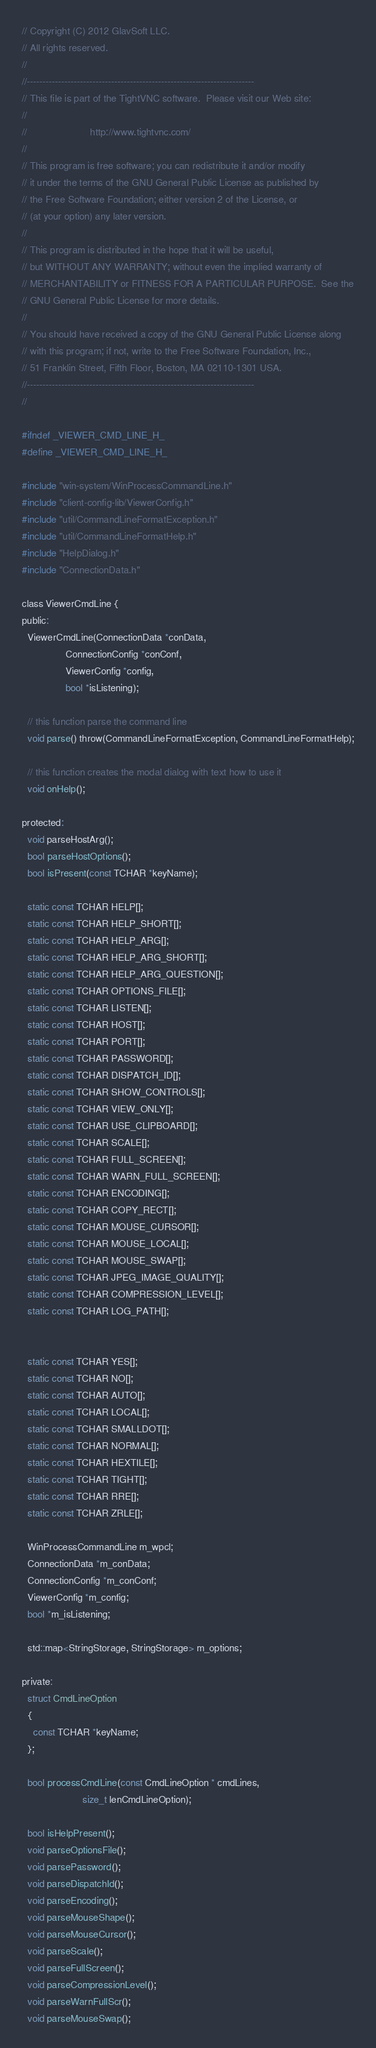Convert code to text. <code><loc_0><loc_0><loc_500><loc_500><_C_>// Copyright (C) 2012 GlavSoft LLC.
// All rights reserved.
//
//-------------------------------------------------------------------------
// This file is part of the TightVNC software.  Please visit our Web site:
//
//                       http://www.tightvnc.com/
//
// This program is free software; you can redistribute it and/or modify
// it under the terms of the GNU General Public License as published by
// the Free Software Foundation; either version 2 of the License, or
// (at your option) any later version.
//
// This program is distributed in the hope that it will be useful,
// but WITHOUT ANY WARRANTY; without even the implied warranty of
// MERCHANTABILITY or FITNESS FOR A PARTICULAR PURPOSE.  See the
// GNU General Public License for more details.
//
// You should have received a copy of the GNU General Public License along
// with this program; if not, write to the Free Software Foundation, Inc.,
// 51 Franklin Street, Fifth Floor, Boston, MA 02110-1301 USA.
//-------------------------------------------------------------------------
//

#ifndef _VIEWER_CMD_LINE_H_
#define _VIEWER_CMD_LINE_H_

#include "win-system/WinProcessCommandLine.h"
#include "client-config-lib/ViewerConfig.h"
#include "util/CommandLineFormatException.h"
#include "util/CommandLineFormatHelp.h"
#include "HelpDialog.h"
#include "ConnectionData.h"

class ViewerCmdLine {
public:
  ViewerCmdLine(ConnectionData *conData,
                ConnectionConfig *conConf,
                ViewerConfig *config,
                bool *isListening);

  // this function parse the command line
  void parse() throw(CommandLineFormatException, CommandLineFormatHelp);

  // this function creates the modal dialog with text how to use it
  void onHelp();

protected:
  void parseHostArg();
  bool parseHostOptions();
  bool isPresent(const TCHAR *keyName);

  static const TCHAR HELP[];
  static const TCHAR HELP_SHORT[];
  static const TCHAR HELP_ARG[];
  static const TCHAR HELP_ARG_SHORT[];
  static const TCHAR HELP_ARG_QUESTION[];
  static const TCHAR OPTIONS_FILE[];
  static const TCHAR LISTEN[];
  static const TCHAR HOST[];
  static const TCHAR PORT[];
  static const TCHAR PASSWORD[];
  static const TCHAR DISPATCH_ID[];
  static const TCHAR SHOW_CONTROLS[];
  static const TCHAR VIEW_ONLY[];
  static const TCHAR USE_CLIPBOARD[];
  static const TCHAR SCALE[];
  static const TCHAR FULL_SCREEN[];
  static const TCHAR WARN_FULL_SCREEN[];
  static const TCHAR ENCODING[];
  static const TCHAR COPY_RECT[];
  static const TCHAR MOUSE_CURSOR[];
  static const TCHAR MOUSE_LOCAL[];
  static const TCHAR MOUSE_SWAP[];
  static const TCHAR JPEG_IMAGE_QUALITY[];
  static const TCHAR COMPRESSION_LEVEL[];
  static const TCHAR LOG_PATH[];


  static const TCHAR YES[];
  static const TCHAR NO[];
  static const TCHAR AUTO[];
  static const TCHAR LOCAL[];
  static const TCHAR SMALLDOT[];
  static const TCHAR NORMAL[];
  static const TCHAR HEXTILE[];
  static const TCHAR TIGHT[];
  static const TCHAR RRE[];
  static const TCHAR ZRLE[];

  WinProcessCommandLine m_wpcl;
  ConnectionData *m_conData;
  ConnectionConfig *m_conConf;
  ViewerConfig *m_config;
  bool *m_isListening;

  std::map<StringStorage, StringStorage> m_options;

private:
  struct CmdLineOption
  {
    const TCHAR *keyName;
  };

  bool processCmdLine(const CmdLineOption * cmdLines, 
                      size_t lenCmdLineOption);

  bool isHelpPresent();
  void parseOptionsFile();
  void parsePassword();
  void parseDispatchId();
  void parseEncoding();
  void parseMouseShape();
  void parseMouseCursor();
  void parseScale();
  void parseFullScreen();
  void parseCompressionLevel();
  void parseWarnFullScr();
  void parseMouseSwap();</code> 